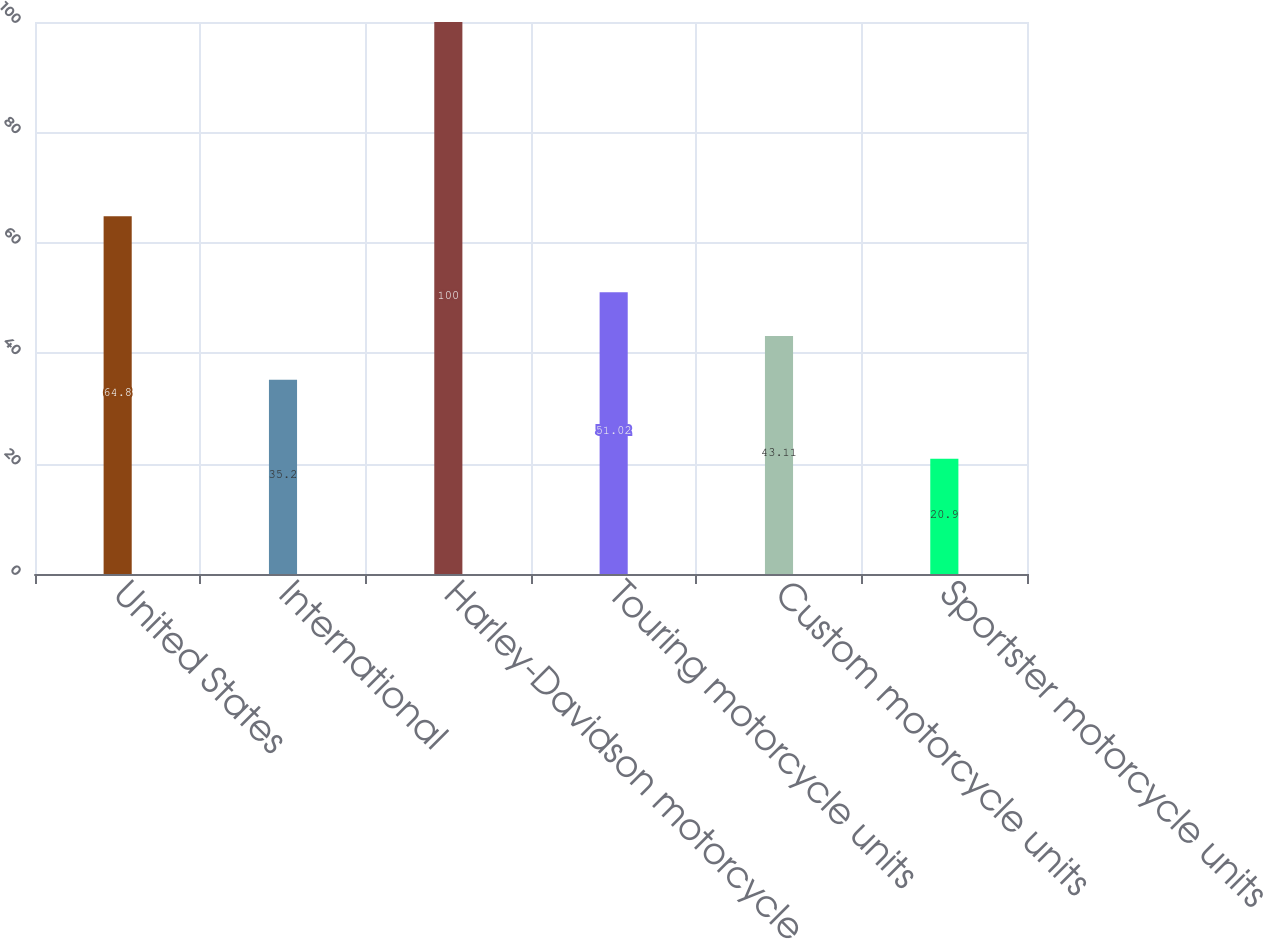Convert chart to OTSL. <chart><loc_0><loc_0><loc_500><loc_500><bar_chart><fcel>United States<fcel>International<fcel>Harley-Davidson motorcycle<fcel>Touring motorcycle units<fcel>Custom motorcycle units<fcel>Sportster motorcycle units<nl><fcel>64.8<fcel>35.2<fcel>100<fcel>51.02<fcel>43.11<fcel>20.9<nl></chart> 